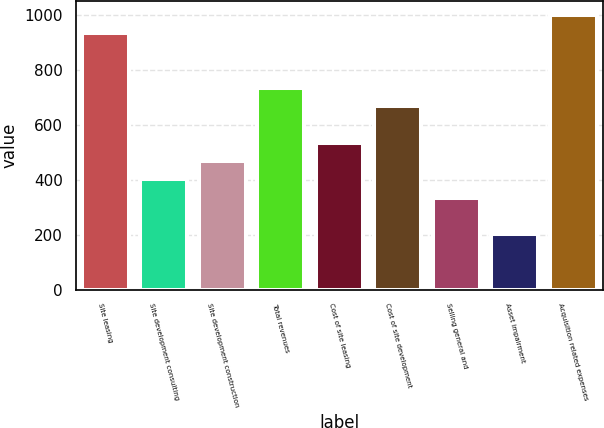Convert chart to OTSL. <chart><loc_0><loc_0><loc_500><loc_500><bar_chart><fcel>Site leasing<fcel>Site development consulting<fcel>Site development construction<fcel>Total revenues<fcel>Cost of site leasing<fcel>Cost of site development<fcel>Selling general and<fcel>Asset impairment<fcel>Acquisition related expenses<nl><fcel>936.2<fcel>401.8<fcel>468.6<fcel>735.8<fcel>535.4<fcel>669<fcel>335<fcel>201.4<fcel>1003<nl></chart> 